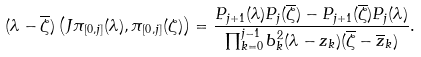Convert formula to latex. <formula><loc_0><loc_0><loc_500><loc_500>( \lambda - \overline { \zeta } ) \left ( J \pi _ { [ 0 , j ] } ( \lambda ) , \pi _ { [ 0 , j ] } ( { \zeta } ) \right ) = \frac { P _ { j + 1 } ( \lambda ) P _ { j } ( \overline { \zeta } ) - P _ { j + 1 } ( \overline { \zeta } ) P _ { j } ( \lambda ) } { \prod _ { k = 0 } ^ { j - 1 } b _ { k } ^ { 2 } ( \lambda - z _ { k } ) ( \overline { \zeta } - \overline { z } _ { k } ) } .</formula> 